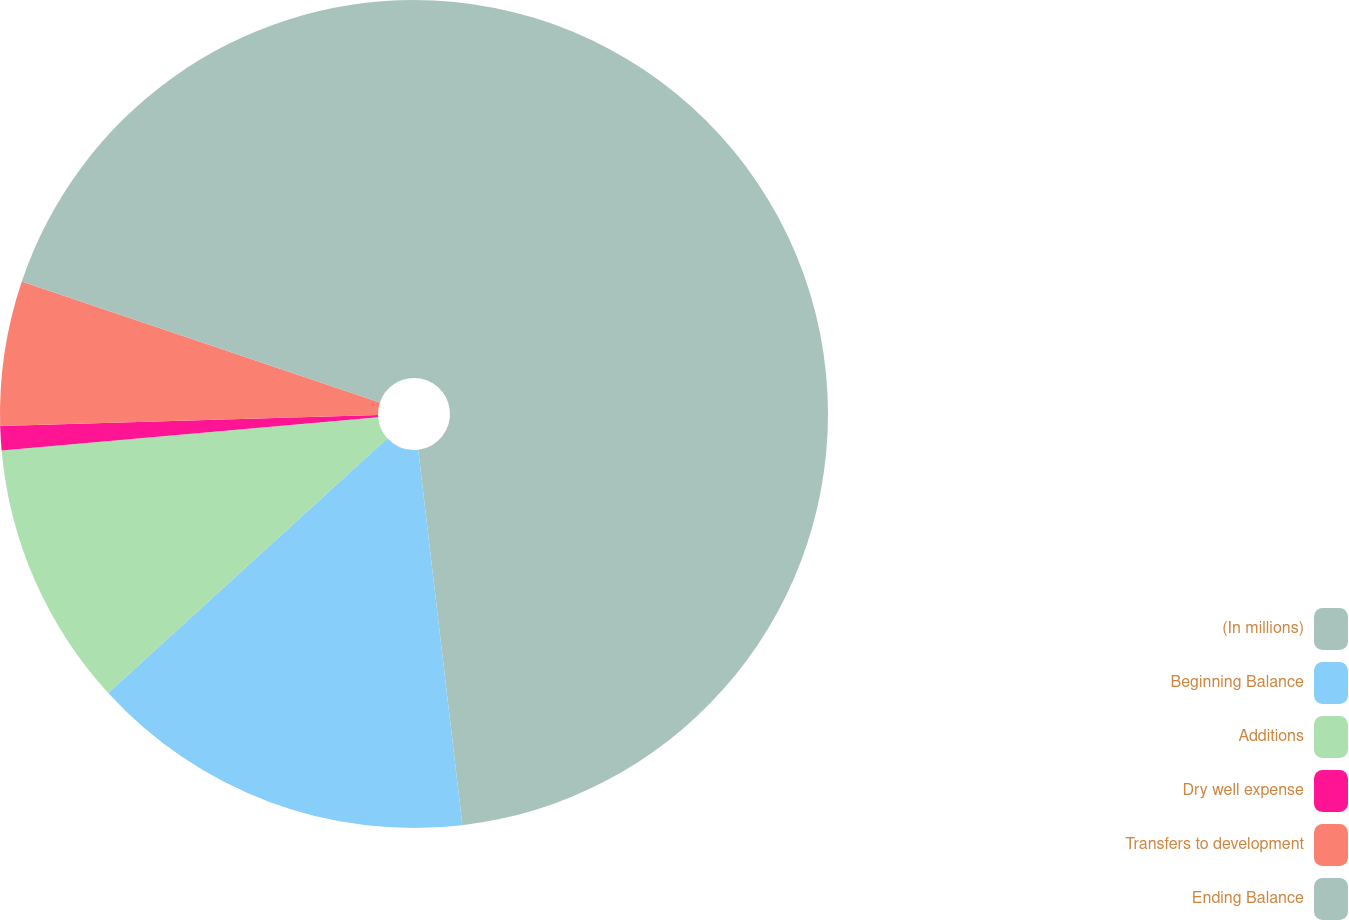Convert chart to OTSL. <chart><loc_0><loc_0><loc_500><loc_500><pie_chart><fcel>(In millions)<fcel>Beginning Balance<fcel>Additions<fcel>Dry well expense<fcel>Transfers to development<fcel>Ending Balance<nl><fcel>48.13%<fcel>15.09%<fcel>10.37%<fcel>0.94%<fcel>5.65%<fcel>19.81%<nl></chart> 